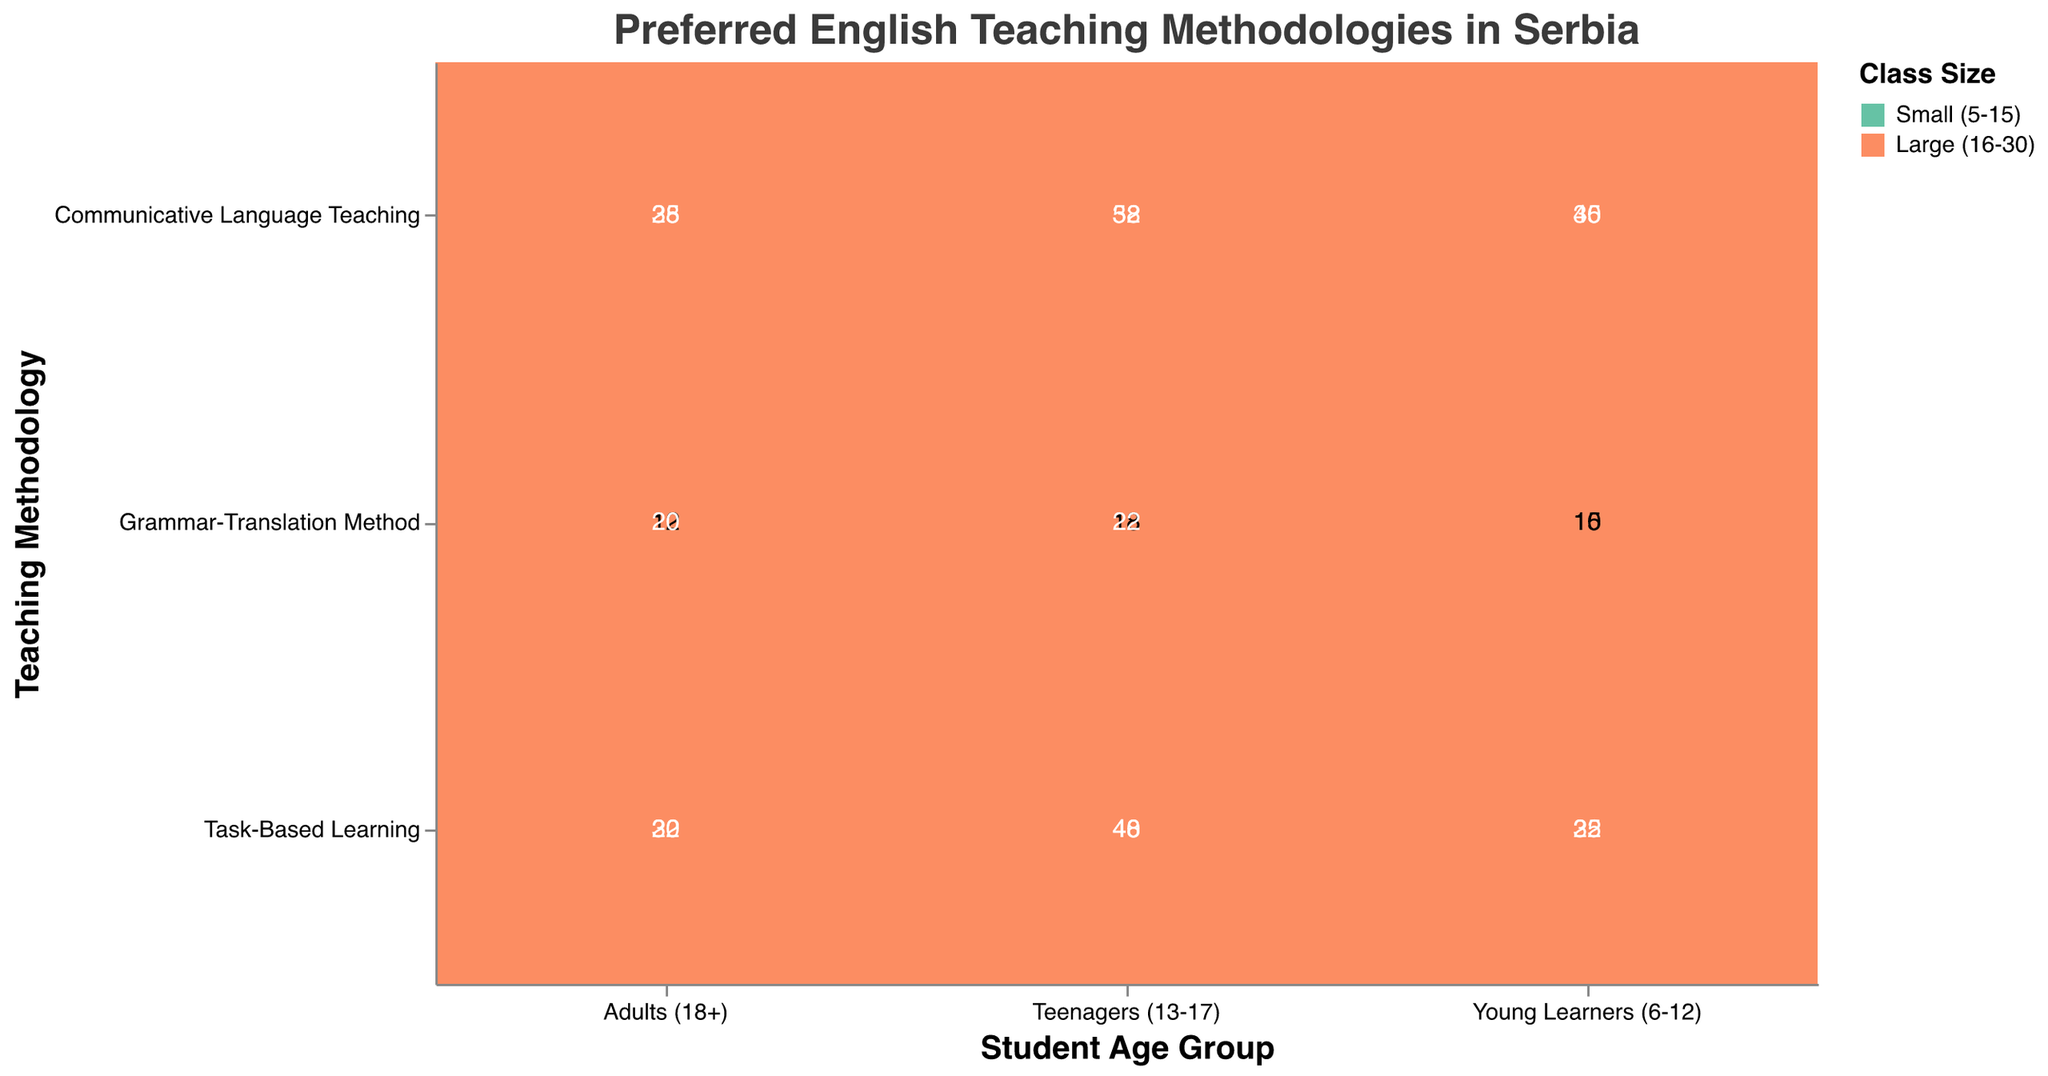How many methodologies are shown in the figure? The figure displays three different teaching methodologies as indicated by the labels on the y-axis, which are "Communicative Language Teaching," "Task-Based Learning," and "Grammar-Translation Method."
Answer: 3 Which student age group has the highest number of counts for the "Grammar-Translation Method"? To find this, look at the "Grammar-Translation Method" row and compare the counts for different student age groups (Young Learners, Teenagers, and Adults). Teenagers have the highest counts with 18 + 22 = 40 total.
Answer: Teenagers (13-17) What is the total count of "Task-Based Learning" for "Young Learners (6-12)"? Sum the counts for both small and large class sizes within the "Task-Based Learning" row for the "Young Learners" column. This is 32 + 25 = 57.
Answer: 57 Which teaching methodology is preferred when considering "Large (16-30)" class sizes for "Adults (18+)"? Compare the counts for "Large (16-30)" class sizes across the methodologies for Adults (18+). "Communicative Language Teaching" has 35, "Task-Based Learning" has 30, and "Grammar-Translation Method" has 20. The highest count is for "Communicative Language Teaching."
Answer: Communicative Language Teaching How does the count differ between "Small (5-15)" and "Large (16-30)" class sizes for "Communicative Language Teaching" for "Teenagers (13-17)"? For "Teenagers (13-17)," look at the counts for "Communicative Language Teaching" in both class sizes. Small class size has 38, and large class size has 52. The difference is 52 - 38 = 14.
Answer: 14 What's the total count for "Young Learners (6-12)" across all methodologies and class sizes? Sum all counts for "Young Learners (6-12)" across the three methodologies and both class sizes. This would be 45 + 30 (Communicative Language Teaching) + 32 + 25 (Task-Based Learning) + 10 + 15 (Grammar-Translation Method) = 157.
Answer: 157 Which class size has a higher total count for the "Task-Based Learning" methodology? To determine this, sum the counts for "Task-Based Learning" across all age groups for each class size. Small (5-15): 32 + 40 + 22 = 94 and Large (16-30): 25 + 48 + 30 = 103. The Large class size has a higher count.
Answer: Large (16-30) Is "Task-Based Learning" more preferred than "Communicative Language Teaching" for "Adults (18+)" when comparing both class sizes? Compare the total count of "Task-Based Learning" and "Communicative Language Teaching" for Adults across both class sizes. "Task-Based Learning": 22 + 30 = 52, and "Communicative Language Teaching": 28 + 35 = 63. "Communicative Language Teaching" is preferred.
Answer: No 